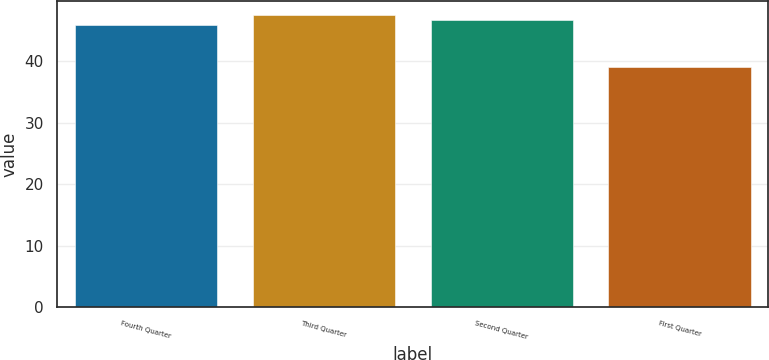Convert chart to OTSL. <chart><loc_0><loc_0><loc_500><loc_500><bar_chart><fcel>Fourth Quarter<fcel>Third Quarter<fcel>Second Quarter<fcel>First Quarter<nl><fcel>45.95<fcel>47.43<fcel>46.69<fcel>38.98<nl></chart> 